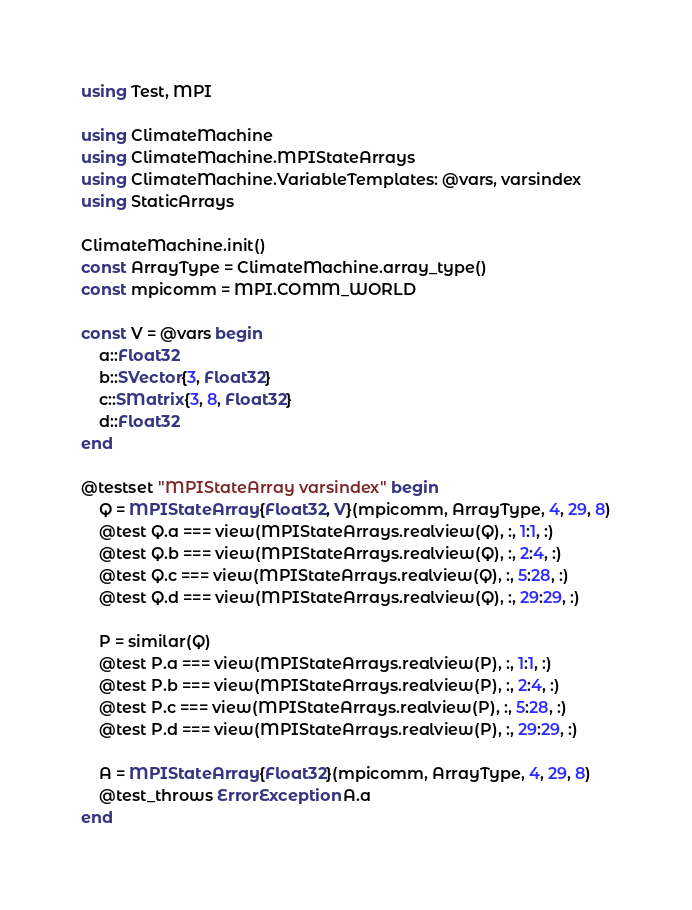Convert code to text. <code><loc_0><loc_0><loc_500><loc_500><_Julia_>using Test, MPI

using ClimateMachine
using ClimateMachine.MPIStateArrays
using ClimateMachine.VariableTemplates: @vars, varsindex
using StaticArrays

ClimateMachine.init()
const ArrayType = ClimateMachine.array_type()
const mpicomm = MPI.COMM_WORLD

const V = @vars begin
    a::Float32
    b::SVector{3, Float32}
    c::SMatrix{3, 8, Float32}
    d::Float32
end

@testset "MPIStateArray varsindex" begin
    Q = MPIStateArray{Float32, V}(mpicomm, ArrayType, 4, 29, 8)
    @test Q.a === view(MPIStateArrays.realview(Q), :, 1:1, :)
    @test Q.b === view(MPIStateArrays.realview(Q), :, 2:4, :)
    @test Q.c === view(MPIStateArrays.realview(Q), :, 5:28, :)
    @test Q.d === view(MPIStateArrays.realview(Q), :, 29:29, :)

    P = similar(Q)
    @test P.a === view(MPIStateArrays.realview(P), :, 1:1, :)
    @test P.b === view(MPIStateArrays.realview(P), :, 2:4, :)
    @test P.c === view(MPIStateArrays.realview(P), :, 5:28, :)
    @test P.d === view(MPIStateArrays.realview(P), :, 29:29, :)

    A = MPIStateArray{Float32}(mpicomm, ArrayType, 4, 29, 8)
    @test_throws ErrorException A.a
end
</code> 